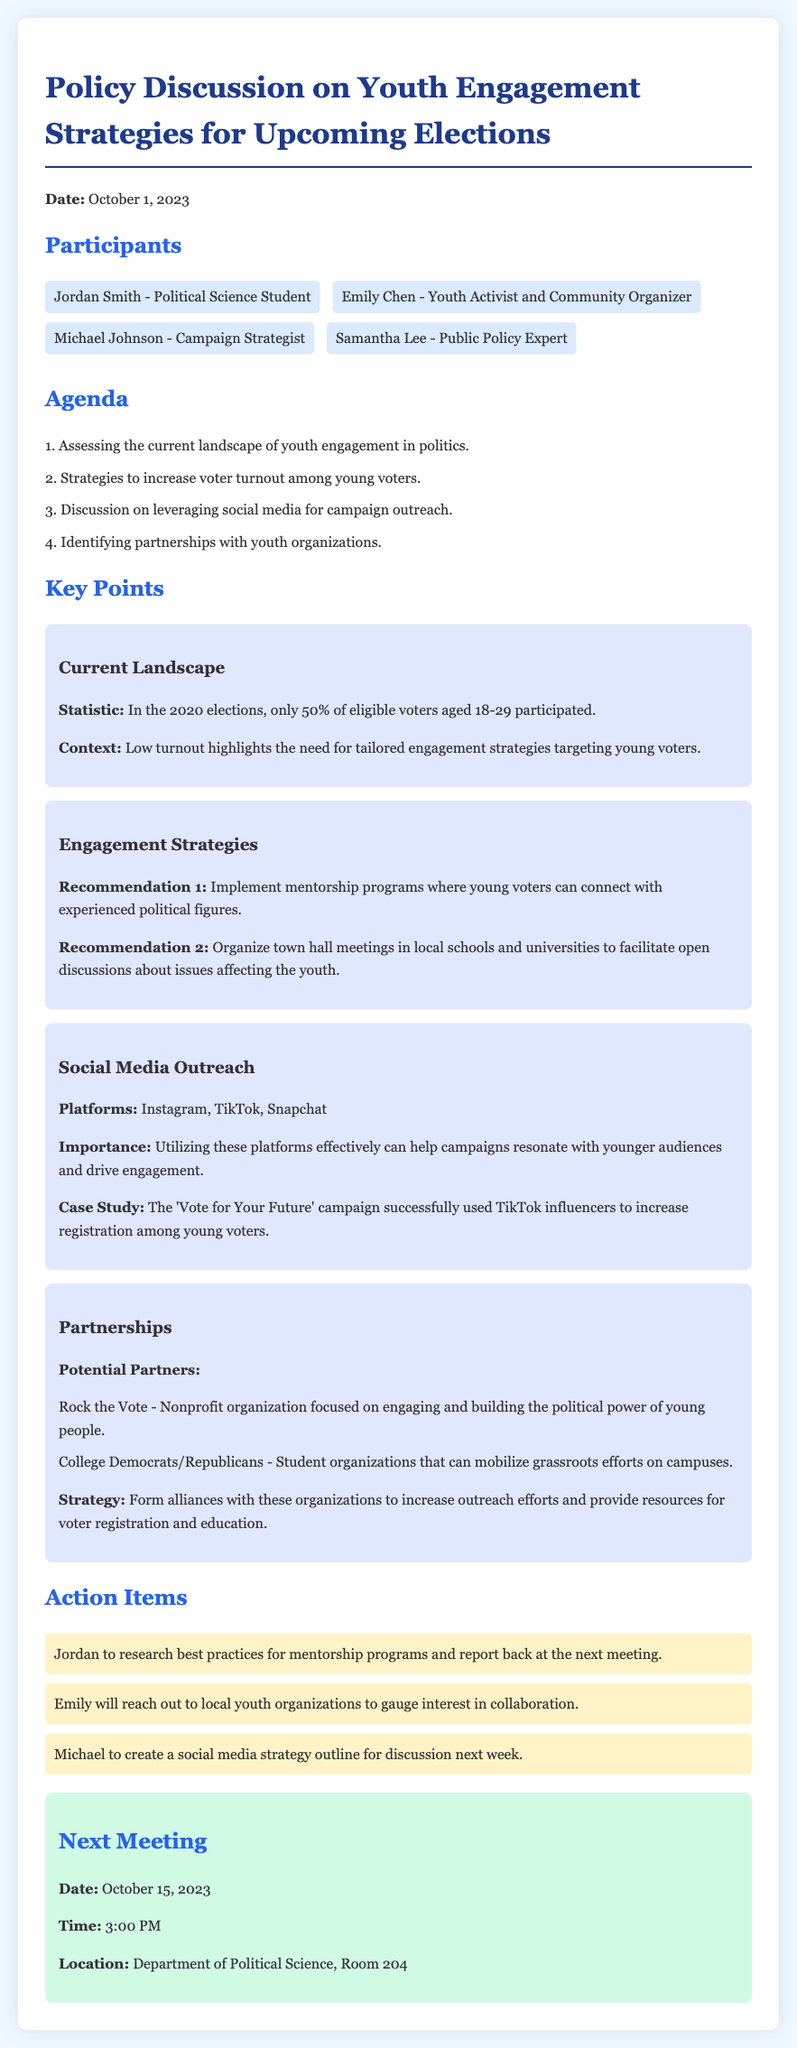What was the date of the meeting? The date of the meeting is stated at the beginning of the document.
Answer: October 1, 2023 Who is the youth activist and community organizer? The document lists Emily Chen as a participant with this role.
Answer: Emily Chen What percentage of eligible voters aged 18-29 participated in the 2020 elections? The document provides this statistic related to youth voter turnout.
Answer: 50% Which social media platforms were highlighted for outreach? The section on social media outreach lists the specific platforms recommended.
Answer: Instagram, TikTok, Snapchat What is one recommended engagement strategy mentioned in the minutes? The minutes list specific recommendations for engaging youth voters.
Answer: Implement mentorship programs How many action items were identified in the meeting? The document lists all the action items decided upon during the meeting.
Answer: 3 What is the date of the next meeting? The date for the follow-up meeting is outlined at the end of the document.
Answer: October 15, 2023 Who is responsible for reaching out to local youth organizations? The minutes specify who will take on this task as an action item.
Answer: Emily What is the key focus of the nonprofit organization "Rock the Vote"? The document provides context about this organization regarding youth engagement.
Answer: Engaging and building the political power of young people 